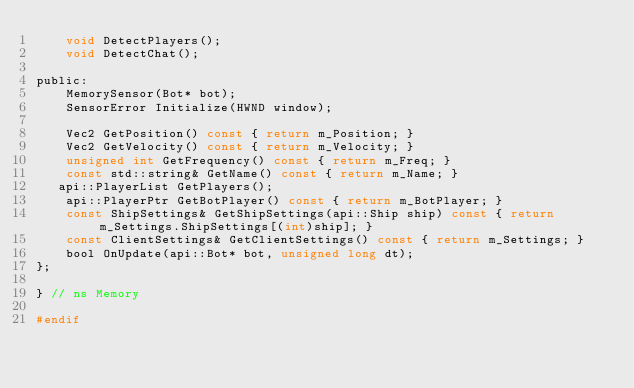Convert code to text. <code><loc_0><loc_0><loc_500><loc_500><_C_>    void DetectPlayers();
    void DetectChat();

public:
    MemorySensor(Bot* bot);
    SensorError Initialize(HWND window);

    Vec2 GetPosition() const { return m_Position; }
    Vec2 GetVelocity() const { return m_Velocity; }
    unsigned int GetFrequency() const { return m_Freq; }
    const std::string& GetName() const { return m_Name; }
   api::PlayerList GetPlayers();
    api::PlayerPtr GetBotPlayer() const { return m_BotPlayer; }
    const ShipSettings& GetShipSettings(api::Ship ship) const { return m_Settings.ShipSettings[(int)ship]; }
    const ClientSettings& GetClientSettings() const { return m_Settings; }
    bool OnUpdate(api::Bot* bot, unsigned long dt);
};

} // ns Memory

#endif
</code> 